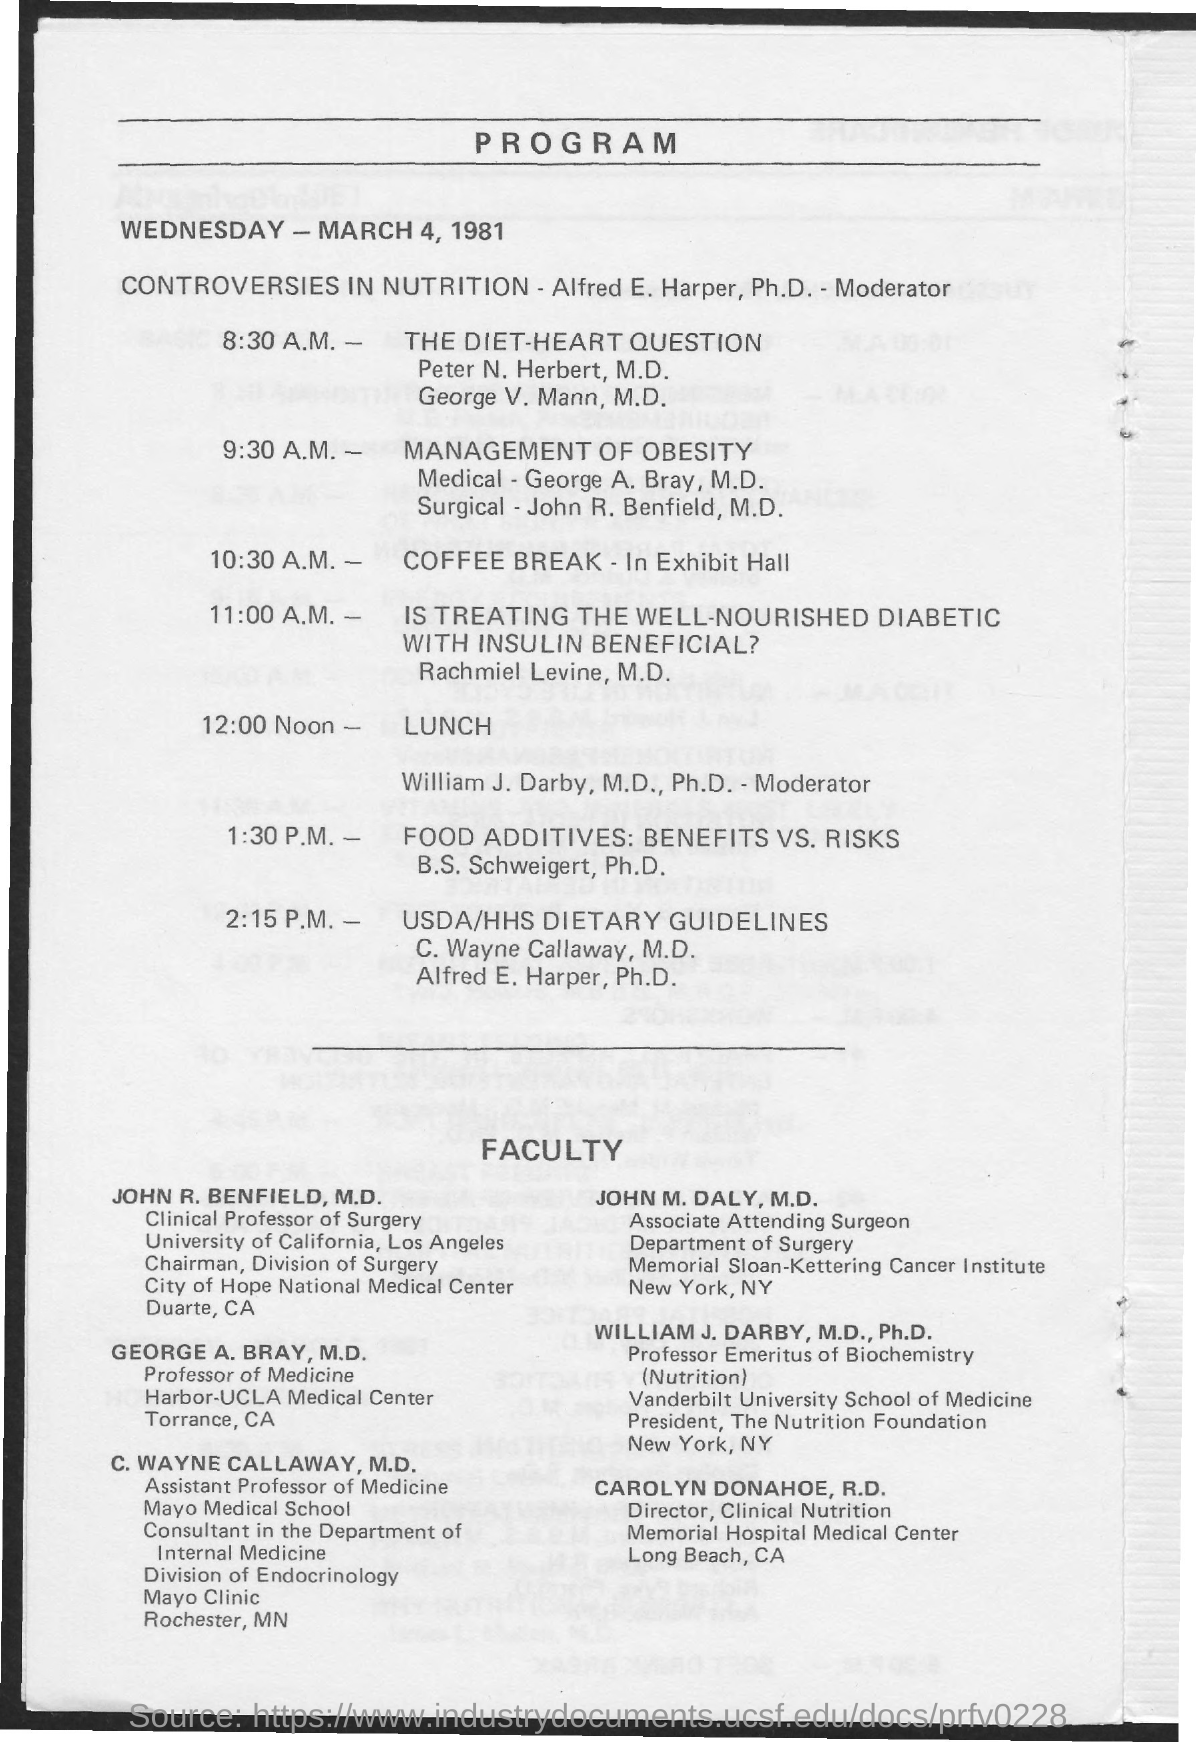When is the coffee break?
Provide a succinct answer. 10:30 A.M. Where is the coffee break?
Make the answer very short. In Exhibit Hall. 